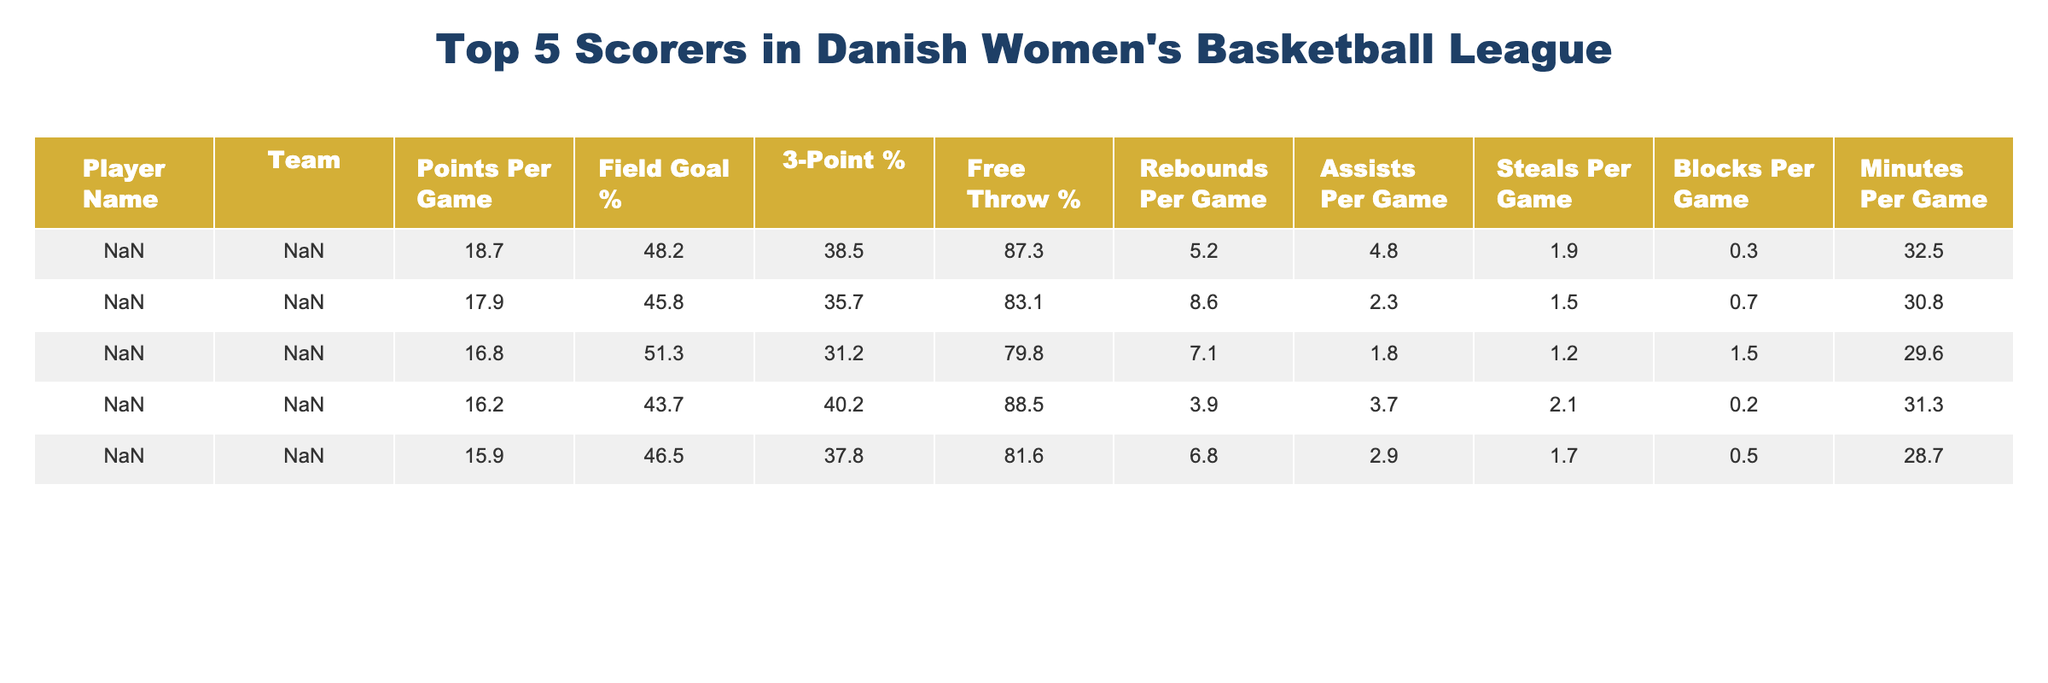What is Gritt Ryder's points per game? Gritt Ryder's points per game is directly listed in the table, where it states she scores 18.7 points per game.
Answer: 18.7 Which player has the highest field goal percentage? The table shows the field goal percentages for all players, and Gritt Ryder has the highest at 48.2%.
Answer: Gritt Ryder How many rebounds per game does Maria Jespersen average? The table lists Maria Jespersen's rebounds per game, which is noted as 8.6.
Answer: 8.6 What is the combined points per game of the top two scorers? The top two scorers are Gritt Ryder (18.7) and Maria Jespersen (17.9). Adding these together gives 18.7 + 17.9 = 36.6.
Answer: 36.6 True or False: Sarah Mortensen has a higher 3-point shooting percentage than Mathilde Gilling. The table lists Sarah Mortensen's 3-point percentage as 37.8% and Mathilde Gilling's as 31.2%. Since 37.8% is greater than 31.2%, the statement is true.
Answer: True What is the average free throw percentage of all five players? To find the average free throw percentage, add all the percentages (87.3 + 83.1 + 79.8 + 88.5 + 81.6 = 420.3) and divide by 5 to get 420.3 / 5 = 84.06.
Answer: 84.06 Which team does Ida Tryggedsson play for? The table indicates that Ida Tryggedsson plays for Aabyhøj IF.
Answer: Aabyhøj IF What is the difference in points per game between Gritt Ryder and Sarah Mortensen? The difference in points per game is calculated by subtracting Sarah Mortensen's points (15.9) from Gritt Ryder's points (18.7), giving 18.7 - 15.9 = 2.8.
Answer: 2.8 Who spends the most minutes on the court per game? The table shows the minutes per game for each player. Gritt Ryder has the most at 32.5 minutes per game.
Answer: Gritt Ryder If total assists per game for all players are summed, what is the total? The total assists per game is calculated by summing the assists: 4.8 + 2.3 + 1.8 + 3.7 + 2.9 = 15.5.
Answer: 15.5 Which player has the lowest blocks per game average? Referring to the table, Ida Tryggedsson has the lowest blocks at 0.2 per game.
Answer: Ida Tryggedsson 